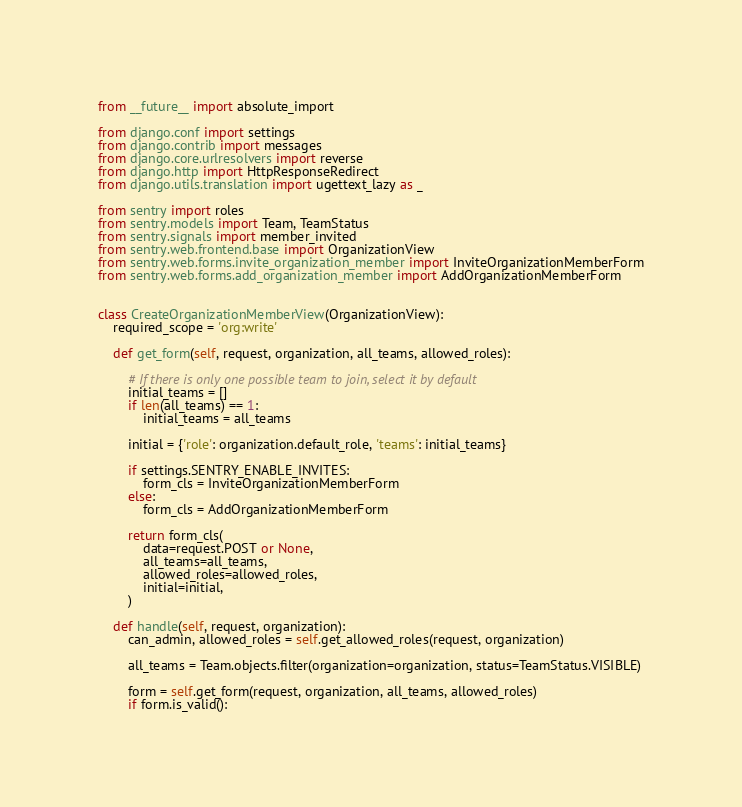Convert code to text. <code><loc_0><loc_0><loc_500><loc_500><_Python_>from __future__ import absolute_import

from django.conf import settings
from django.contrib import messages
from django.core.urlresolvers import reverse
from django.http import HttpResponseRedirect
from django.utils.translation import ugettext_lazy as _

from sentry import roles
from sentry.models import Team, TeamStatus
from sentry.signals import member_invited
from sentry.web.frontend.base import OrganizationView
from sentry.web.forms.invite_organization_member import InviteOrganizationMemberForm
from sentry.web.forms.add_organization_member import AddOrganizationMemberForm


class CreateOrganizationMemberView(OrganizationView):
    required_scope = 'org:write'

    def get_form(self, request, organization, all_teams, allowed_roles):

        # If there is only one possible team to join, select it by default
        initial_teams = []
        if len(all_teams) == 1:
            initial_teams = all_teams

        initial = {'role': organization.default_role, 'teams': initial_teams}

        if settings.SENTRY_ENABLE_INVITES:
            form_cls = InviteOrganizationMemberForm
        else:
            form_cls = AddOrganizationMemberForm

        return form_cls(
            data=request.POST or None,
            all_teams=all_teams,
            allowed_roles=allowed_roles,
            initial=initial,
        )

    def handle(self, request, organization):
        can_admin, allowed_roles = self.get_allowed_roles(request, organization)

        all_teams = Team.objects.filter(organization=organization, status=TeamStatus.VISIBLE)

        form = self.get_form(request, organization, all_teams, allowed_roles)
        if form.is_valid():</code> 